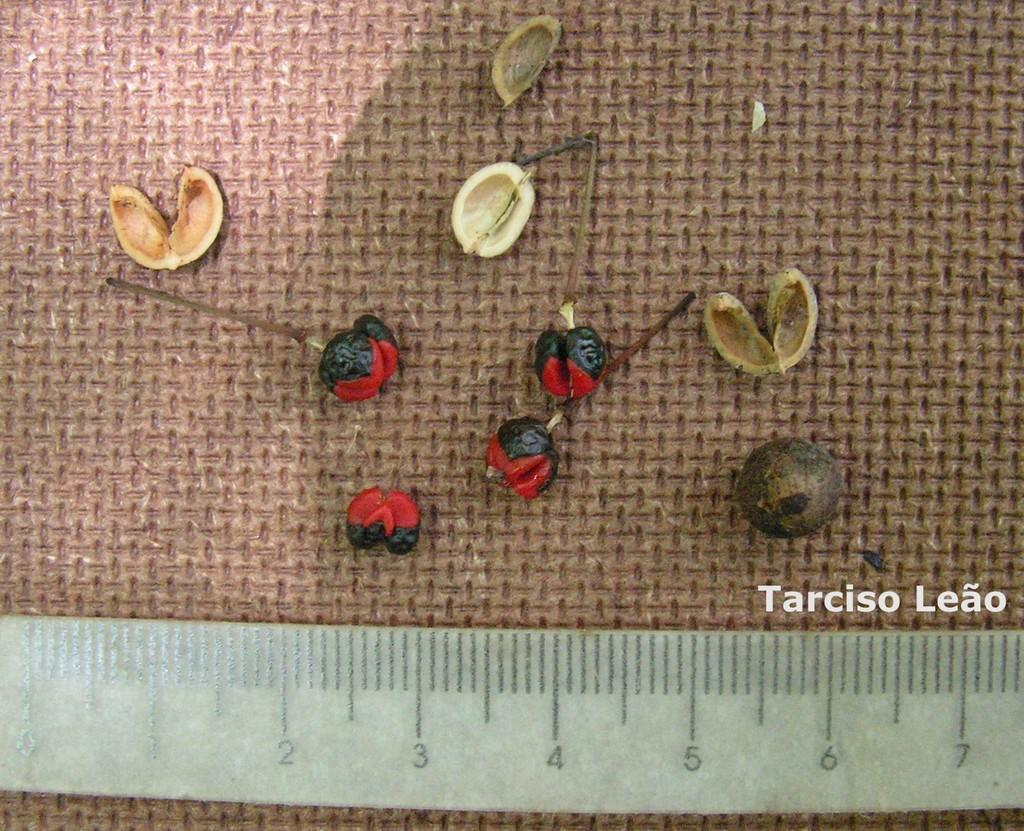<image>
Describe the image concisely. a ruler that has many numbers and tarciso leao on it 